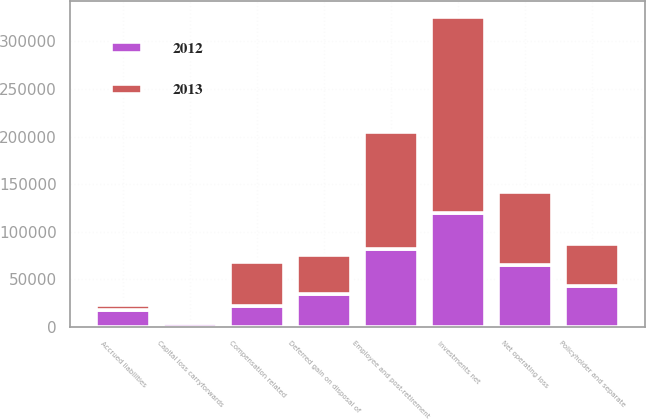Convert chart to OTSL. <chart><loc_0><loc_0><loc_500><loc_500><stacked_bar_chart><ecel><fcel>Policyholder and separate<fcel>Accrued liabilities<fcel>Investments net<fcel>Net operating loss<fcel>Capital loss carryforwards<fcel>Deferred gain on disposal of<fcel>Compensation related<fcel>Employee and post-retirement<nl><fcel>2012<fcel>43505<fcel>17791<fcel>119410<fcel>65507<fcel>4297<fcel>34833<fcel>21713<fcel>81725<nl><fcel>2013<fcel>43505<fcel>5295<fcel>206517<fcel>75828<fcel>0<fcel>40554<fcel>46456<fcel>122599<nl></chart> 